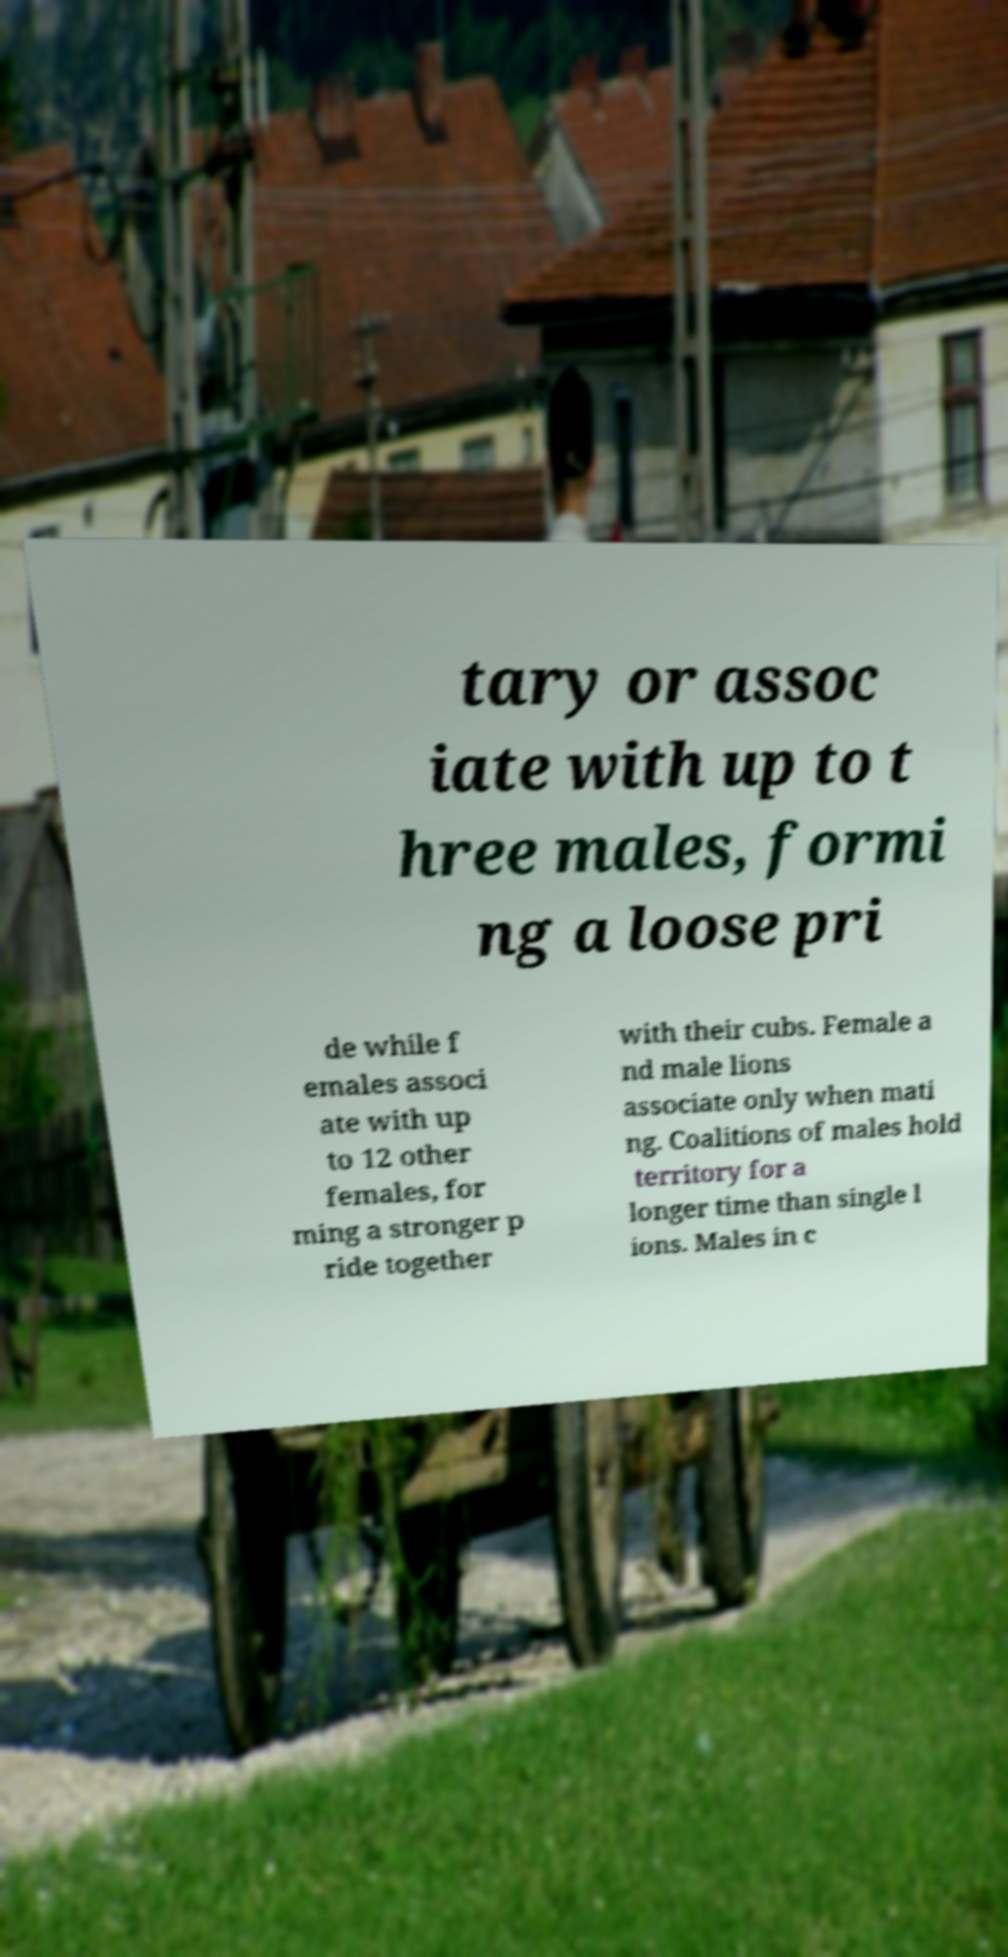Can you accurately transcribe the text from the provided image for me? tary or assoc iate with up to t hree males, formi ng a loose pri de while f emales associ ate with up to 12 other females, for ming a stronger p ride together with their cubs. Female a nd male lions associate only when mati ng. Coalitions of males hold territory for a longer time than single l ions. Males in c 